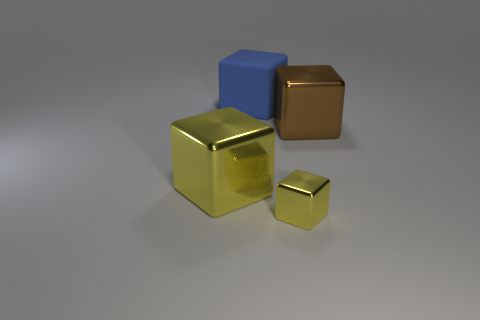Add 3 large blocks. How many objects exist? 7 Add 4 tiny red rubber objects. How many tiny red rubber objects exist? 4 Subtract 0 purple spheres. How many objects are left? 4 Subtract all small metal things. Subtract all blue rubber blocks. How many objects are left? 2 Add 3 tiny yellow shiny things. How many tiny yellow shiny things are left? 4 